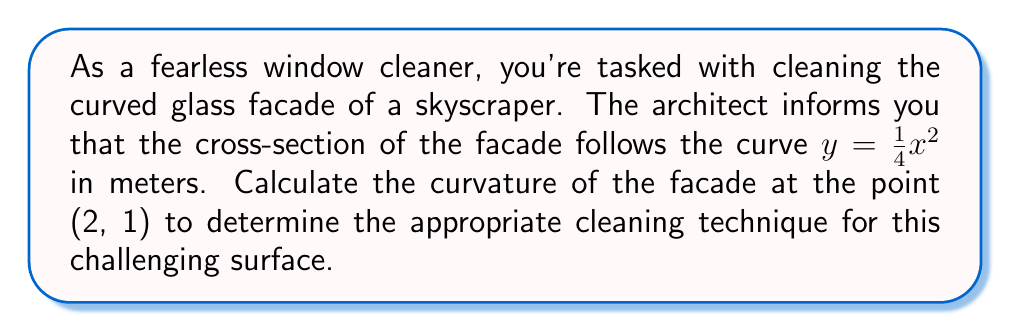Help me with this question. To calculate the curvature of the skyscraper's curved glass facade, we'll follow these steps:

1) The curvature $\kappa$ of a curve $y = f(x)$ at a point $(x, y)$ is given by:

   $$\kappa = \frac{|f''(x)|}{(1 + [f'(x)]^2)^{3/2}}$$

2) For our curve $y = \frac{1}{4}x^2$, we need to find $f'(x)$ and $f''(x)$:
   
   $f'(x) = \frac{1}{2}x$
   $f''(x) = \frac{1}{2}$

3) At the point (2, 1), $x = 2$. Let's substitute this into $f'(x)$:
   
   $f'(2) = \frac{1}{2}(2) = 1$

4) Now we can substitute all values into the curvature formula:

   $$\kappa = \frac{|\frac{1}{2}|}{(1 + [1]^2)^{3/2}}$$

5) Simplify:
   
   $$\kappa = \frac{0.5}{(1 + 1)^{3/2}} = \frac{0.5}{2^{3/2}} = \frac{0.5}{2\sqrt{2}}$$

6) Further simplify:
   
   $$\kappa = \frac{1}{4\sqrt{2}} \approx 0.1768 \text{ m}^{-1}$$

This curvature value indicates how sharply the facade is curving at the point (2, 1), which will inform your cleaning technique.
Answer: $\frac{1}{4\sqrt{2}} \text{ m}^{-1}$ 